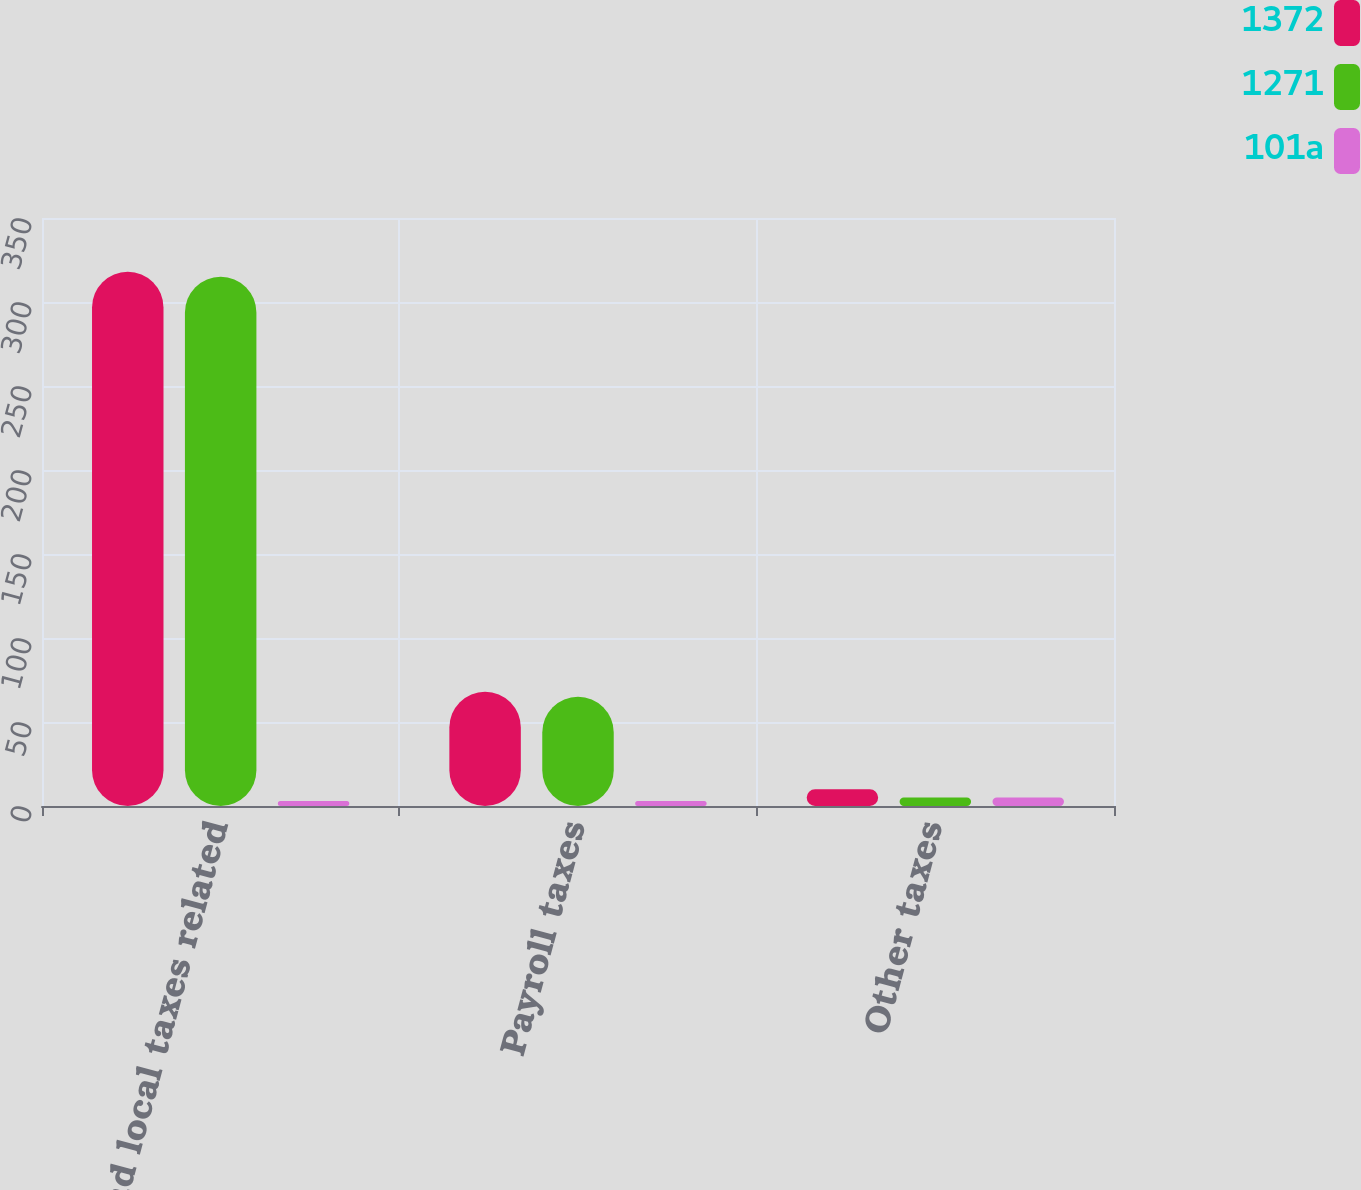Convert chart. <chart><loc_0><loc_0><loc_500><loc_500><stacked_bar_chart><ecel><fcel>State and local taxes related<fcel>Payroll taxes<fcel>Other taxes<nl><fcel>1372<fcel>318<fcel>68<fcel>10<nl><fcel>1271<fcel>315<fcel>65<fcel>5<nl><fcel>101a<fcel>3<fcel>3<fcel>5<nl></chart> 